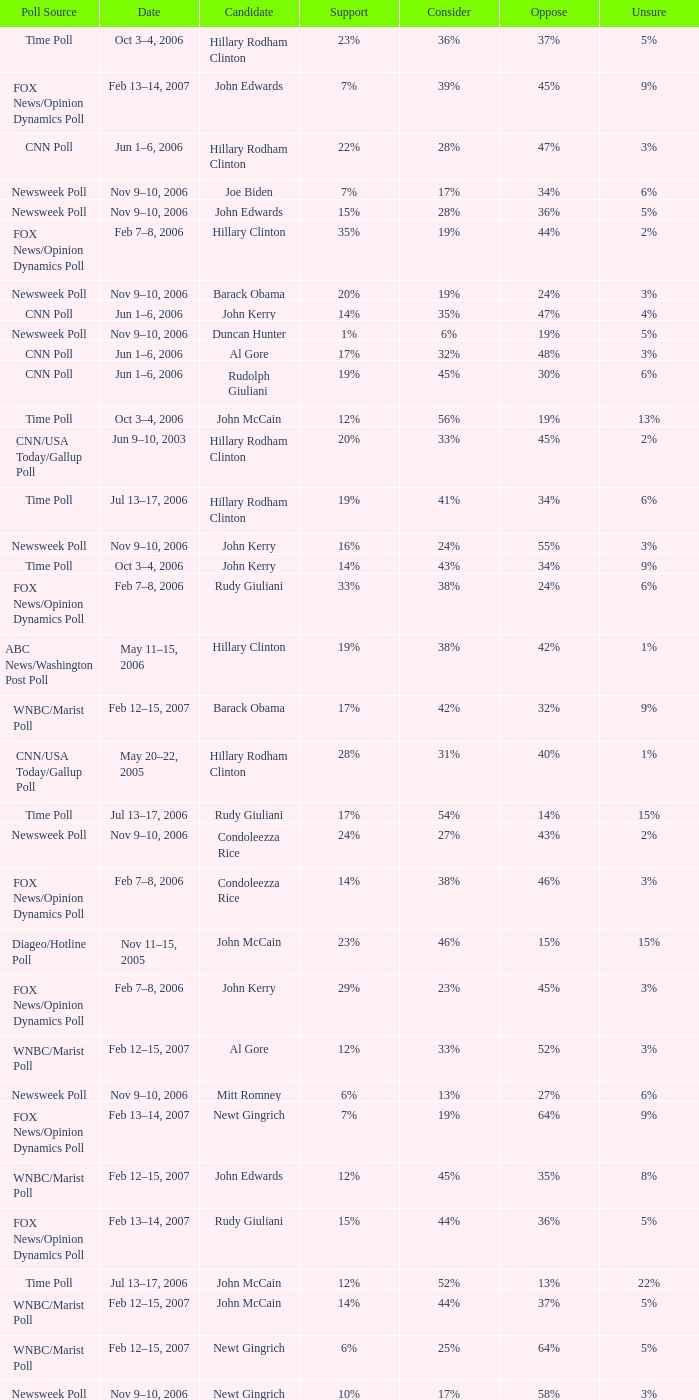Parse the full table. {'header': ['Poll Source', 'Date', 'Candidate', 'Support', 'Consider', 'Oppose', 'Unsure'], 'rows': [['Time Poll', 'Oct 3–4, 2006', 'Hillary Rodham Clinton', '23%', '36%', '37%', '5%'], ['FOX News/Opinion Dynamics Poll', 'Feb 13–14, 2007', 'John Edwards', '7%', '39%', '45%', '9%'], ['CNN Poll', 'Jun 1–6, 2006', 'Hillary Rodham Clinton', '22%', '28%', '47%', '3%'], ['Newsweek Poll', 'Nov 9–10, 2006', 'Joe Biden', '7%', '17%', '34%', '6%'], ['Newsweek Poll', 'Nov 9–10, 2006', 'John Edwards', '15%', '28%', '36%', '5%'], ['FOX News/Opinion Dynamics Poll', 'Feb 7–8, 2006', 'Hillary Clinton', '35%', '19%', '44%', '2%'], ['Newsweek Poll', 'Nov 9–10, 2006', 'Barack Obama', '20%', '19%', '24%', '3%'], ['CNN Poll', 'Jun 1–6, 2006', 'John Kerry', '14%', '35%', '47%', '4%'], ['Newsweek Poll', 'Nov 9–10, 2006', 'Duncan Hunter', '1%', '6%', '19%', '5%'], ['CNN Poll', 'Jun 1–6, 2006', 'Al Gore', '17%', '32%', '48%', '3%'], ['CNN Poll', 'Jun 1–6, 2006', 'Rudolph Giuliani', '19%', '45%', '30%', '6%'], ['Time Poll', 'Oct 3–4, 2006', 'John McCain', '12%', '56%', '19%', '13%'], ['CNN/USA Today/Gallup Poll', 'Jun 9–10, 2003', 'Hillary Rodham Clinton', '20%', '33%', '45%', '2%'], ['Time Poll', 'Jul 13–17, 2006', 'Hillary Rodham Clinton', '19%', '41%', '34%', '6%'], ['Newsweek Poll', 'Nov 9–10, 2006', 'John Kerry', '16%', '24%', '55%', '3%'], ['Time Poll', 'Oct 3–4, 2006', 'John Kerry', '14%', '43%', '34%', '9%'], ['FOX News/Opinion Dynamics Poll', 'Feb 7–8, 2006', 'Rudy Giuliani', '33%', '38%', '24%', '6%'], ['ABC News/Washington Post Poll', 'May 11–15, 2006', 'Hillary Clinton', '19%', '38%', '42%', '1%'], ['WNBC/Marist Poll', 'Feb 12–15, 2007', 'Barack Obama', '17%', '42%', '32%', '9%'], ['CNN/USA Today/Gallup Poll', 'May 20–22, 2005', 'Hillary Rodham Clinton', '28%', '31%', '40%', '1%'], ['Time Poll', 'Jul 13–17, 2006', 'Rudy Giuliani', '17%', '54%', '14%', '15%'], ['Newsweek Poll', 'Nov 9–10, 2006', 'Condoleezza Rice', '24%', '27%', '43%', '2%'], ['FOX News/Opinion Dynamics Poll', 'Feb 7–8, 2006', 'Condoleezza Rice', '14%', '38%', '46%', '3%'], ['Diageo/Hotline Poll', 'Nov 11–15, 2005', 'John McCain', '23%', '46%', '15%', '15%'], ['FOX News/Opinion Dynamics Poll', 'Feb 7–8, 2006', 'John Kerry', '29%', '23%', '45%', '3%'], ['WNBC/Marist Poll', 'Feb 12–15, 2007', 'Al Gore', '12%', '33%', '52%', '3%'], ['Newsweek Poll', 'Nov 9–10, 2006', 'Mitt Romney', '6%', '13%', '27%', '6%'], ['FOX News/Opinion Dynamics Poll', 'Feb 13–14, 2007', 'Newt Gingrich', '7%', '19%', '64%', '9%'], ['WNBC/Marist Poll', 'Feb 12–15, 2007', 'John Edwards', '12%', '45%', '35%', '8%'], ['FOX News/Opinion Dynamics Poll', 'Feb 13–14, 2007', 'Rudy Giuliani', '15%', '44%', '36%', '5%'], ['Time Poll', 'Jul 13–17, 2006', 'John McCain', '12%', '52%', '13%', '22%'], ['WNBC/Marist Poll', 'Feb 12–15, 2007', 'John McCain', '14%', '44%', '37%', '5%'], ['WNBC/Marist Poll', 'Feb 12–15, 2007', 'Newt Gingrich', '6%', '25%', '64%', '5%'], ['Newsweek Poll', 'Nov 9–10, 2006', 'Newt Gingrich', '10%', '17%', '58%', '3%'], ['Time Poll', 'Jul 13–17, 2006', 'Al Gore', '16%', '45%', '32%', '7%'], ['FOX News/Opinion Dynamics Poll', 'Feb 13–14, 2007', 'Hillary Clinton', '18%', '34%', '44%', '3%'], ['Time Poll', 'Jul 13–17, 2006', 'John Kerry', '12%', '48%', '30%', '10%'], ['FOX News/Opinion Dynamics Poll', 'Feb 7–8, 2006', 'John McCain', '30%', '40%', '22%', '7%'], ['Newsweek Poll', 'Nov 9–10, 2006', 'Sam Brownback', '3%', '7%', '23%', '6%'], ['CNN Poll', 'Jun 1–6, 2006', 'Jeb Bush', '9%', '26%', '63%', '2%'], ['Time Poll', 'Oct 3–4, 2006', 'Rudy Giuliani', '17%', '55%', '19%', '18%'], ['ABC News/Washington Post Poll', 'May 11–15, 2006', 'John McCain', '9%', '57%', '28%', '6%'], ['Newsweek Poll', 'Nov 9–10, 2006', 'Rudy Giuliani', '24%', '30%', '32%', '4%'], ['Newsweek Poll', 'Nov 9–10, 2006', 'Al Gore', '21%', '24%', '53%', '2%'], ['CNN/USA Today/Gallup Poll', 'Jan 20–22, 2006', 'Hillary Rodham Clinton', '16%', '32%', '51%', '1%'], ['Time Poll', 'Oct 3–4, 2006', 'Al Gore', '16%', '44%', '35%', '5%'], ['CNN Poll', 'Jun 1–6, 2006', 'John McCain', '12%', '48%', '34%', '6%'], ['WNBC/Marist Poll', 'Feb 12–15, 2007', 'Mitt Romney', '7%', '25%', '44%', '24%'], ['FOX News/Opinion Dynamics Poll', 'Feb 13–14, 2007', 'Ralph Nader', '3%', '14%', '76%', '8%'], ['WNBC/Marist Poll', 'Feb 12–15, 2007', 'Rudy Giuliani', '16%', '51%', '30%', '3%'], ['FOX News/Opinion Dynamics Poll', 'Feb 13–14, 2007', 'Barack Obama', '12%', '45%', '34%', '10%'], ['Newsweek Poll', 'Nov 9–10, 2006', 'Hillary Clinton', '33%', '20%', '45%', '2%'], ['WNBC/Marist Poll', 'Feb 12–15, 2007', 'Hillary Clinton', '25%', '30%', '43%', '2%'], ['FOX News/Opinion Dynamics Poll', 'Feb 13–14, 2007', 'John McCain', '9%', '43%', '40%', '8%'], ['Newsweek Poll', 'Nov 9–10, 2006', 'John McCain', '20%', '34%', '32%', '4%']]} What percentage of people said they would consider Rudy Giuliani as a candidate according to the Newsweek poll that showed 32% opposed him? 30%. 